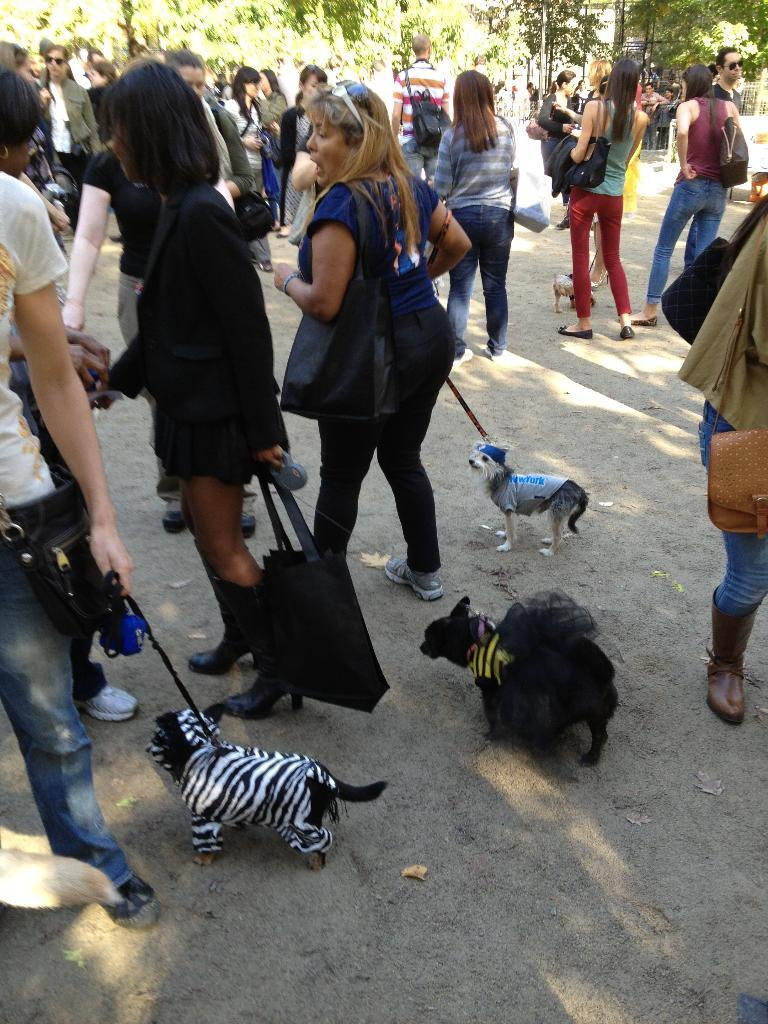What are the people in the image doing? The people in the image are walking on the road. What are the people holding while walking on the road? The people are holding puppies. What can be seen in the background of the image? There are trees visible in the background. Are the people wearing masks while walking on the road? There is no mention of masks in the image, so it cannot be determined if the people are wearing masks. Can you tell me how many geese are walking alongside the people in the image? There is no mention of geese in the image; it only features people walking on the road and holding puppies. 